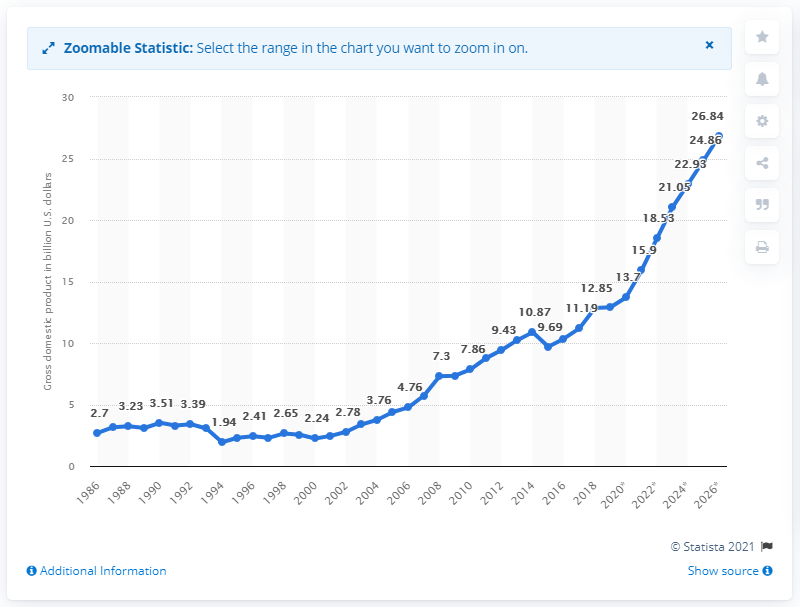List a handful of essential elements in this visual. Niger's Gross Domestic Product in 2019 was 12.91. 